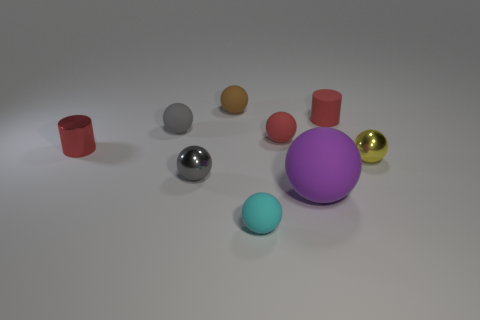The small matte object that is the same color as the rubber cylinder is what shape?
Make the answer very short. Sphere. There is a rubber cylinder that is the same color as the metal cylinder; what size is it?
Your answer should be compact. Small. What material is the cylinder on the left side of the tiny rubber ball behind the small red cylinder on the right side of the red ball?
Give a very brief answer. Metal. How many things are either gray shiny spheres or tiny shiny cylinders?
Provide a succinct answer. 2. Is there anything else that has the same material as the tiny cyan sphere?
Provide a short and direct response. Yes. What is the shape of the small cyan rubber thing?
Keep it short and to the point. Sphere. The small gray object to the right of the small matte object that is on the left side of the gray metal thing is what shape?
Your answer should be compact. Sphere. Are the red cylinder that is on the right side of the small red ball and the small brown thing made of the same material?
Keep it short and to the point. Yes. How many yellow objects are either large rubber things or tiny shiny cylinders?
Keep it short and to the point. 0. Is there a rubber cylinder that has the same color as the big object?
Your response must be concise. No. 